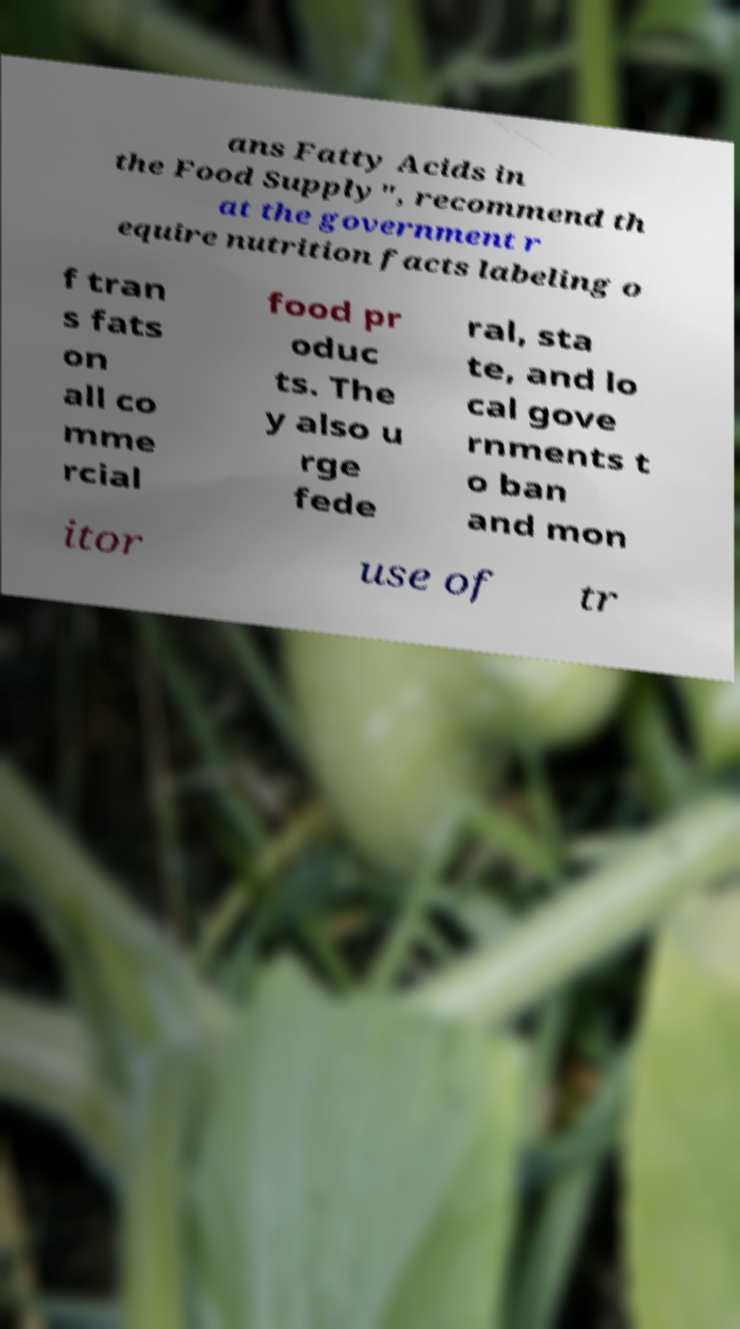Please identify and transcribe the text found in this image. ans Fatty Acids in the Food Supply", recommend th at the government r equire nutrition facts labeling o f tran s fats on all co mme rcial food pr oduc ts. The y also u rge fede ral, sta te, and lo cal gove rnments t o ban and mon itor use of tr 